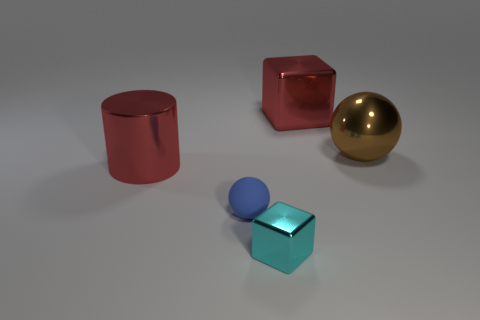How could these objects be used in a learning or educational context? These objects, with their distinct shapes and colors, could be used for a variety of educational purposes, such as teaching about geometry, spatial relationships, and color theory. For example, a teacher might use them to explain the concept of volume and surface area, or to illustrate how light interacts with different materials and textures. 